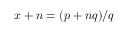Convert formula to latex. <formula><loc_0><loc_0><loc_500><loc_500>x + n = ( p + n q ) / q</formula> 